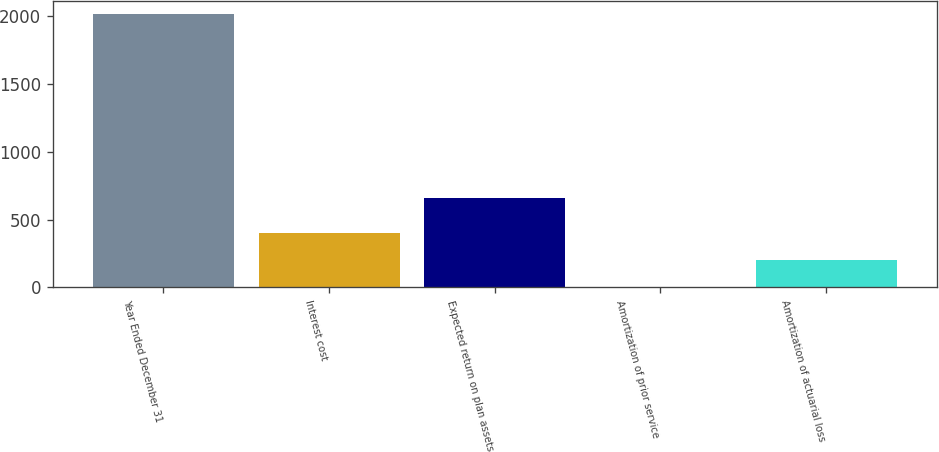Convert chart to OTSL. <chart><loc_0><loc_0><loc_500><loc_500><bar_chart><fcel>Year Ended December 31<fcel>Interest cost<fcel>Expected return on plan assets<fcel>Amortization of prior service<fcel>Amortization of actuarial loss<nl><fcel>2013<fcel>404.2<fcel>659<fcel>2<fcel>203.1<nl></chart> 